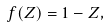Convert formula to latex. <formula><loc_0><loc_0><loc_500><loc_500>f ( Z ) = 1 - Z ,</formula> 